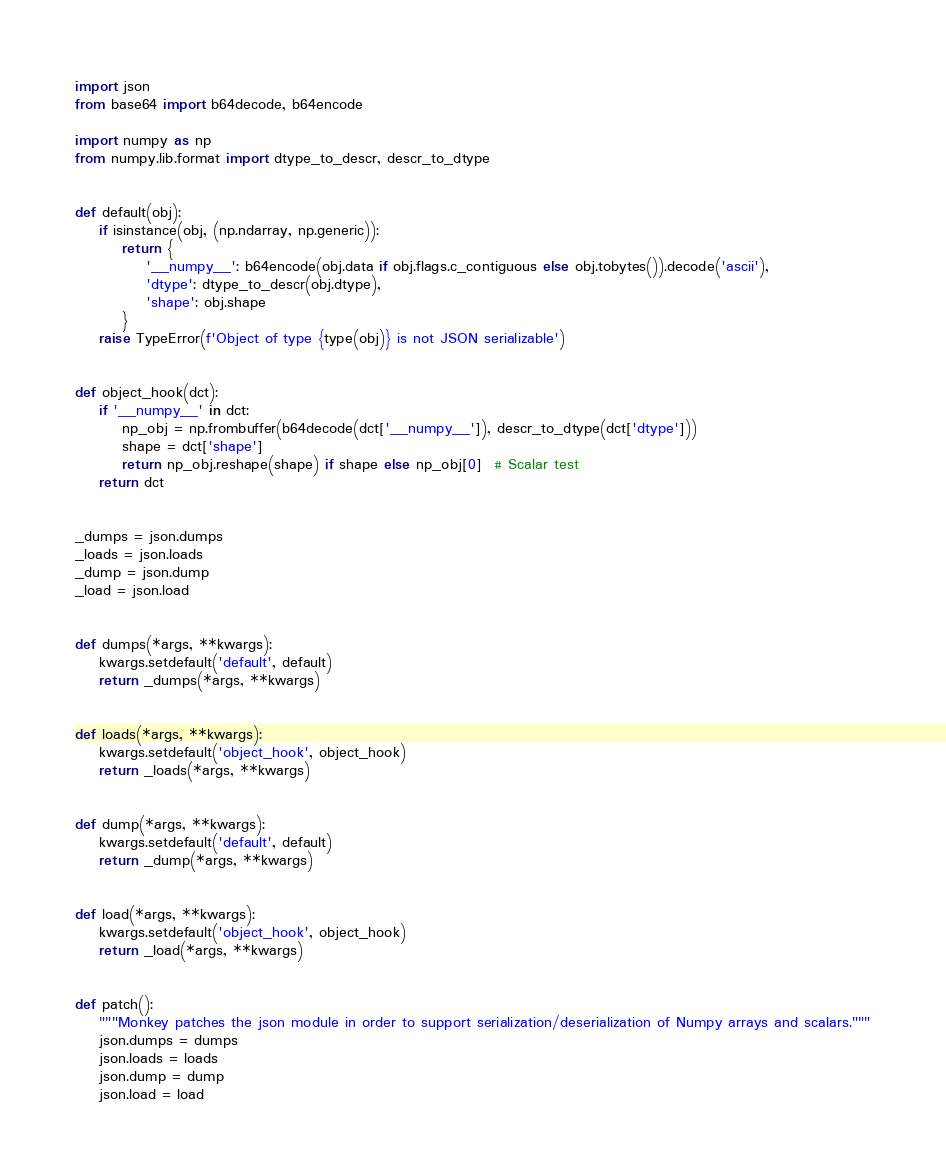<code> <loc_0><loc_0><loc_500><loc_500><_Python_>import json
from base64 import b64decode, b64encode

import numpy as np
from numpy.lib.format import dtype_to_descr, descr_to_dtype


def default(obj):
    if isinstance(obj, (np.ndarray, np.generic)):
        return {
            '__numpy__': b64encode(obj.data if obj.flags.c_contiguous else obj.tobytes()).decode('ascii'),
            'dtype': dtype_to_descr(obj.dtype),
            'shape': obj.shape
        }
    raise TypeError(f'Object of type {type(obj)} is not JSON serializable')


def object_hook(dct):
    if '__numpy__' in dct:
        np_obj = np.frombuffer(b64decode(dct['__numpy__']), descr_to_dtype(dct['dtype']))
        shape = dct['shape']
        return np_obj.reshape(shape) if shape else np_obj[0]  # Scalar test
    return dct


_dumps = json.dumps
_loads = json.loads
_dump = json.dump
_load = json.load


def dumps(*args, **kwargs):
    kwargs.setdefault('default', default)
    return _dumps(*args, **kwargs)


def loads(*args, **kwargs):
    kwargs.setdefault('object_hook', object_hook)
    return _loads(*args, **kwargs)


def dump(*args, **kwargs):
    kwargs.setdefault('default', default)
    return _dump(*args, **kwargs)


def load(*args, **kwargs):
    kwargs.setdefault('object_hook', object_hook)
    return _load(*args, **kwargs)


def patch():
    """Monkey patches the json module in order to support serialization/deserialization of Numpy arrays and scalars."""
    json.dumps = dumps
    json.loads = loads
    json.dump = dump
    json.load = load
</code> 